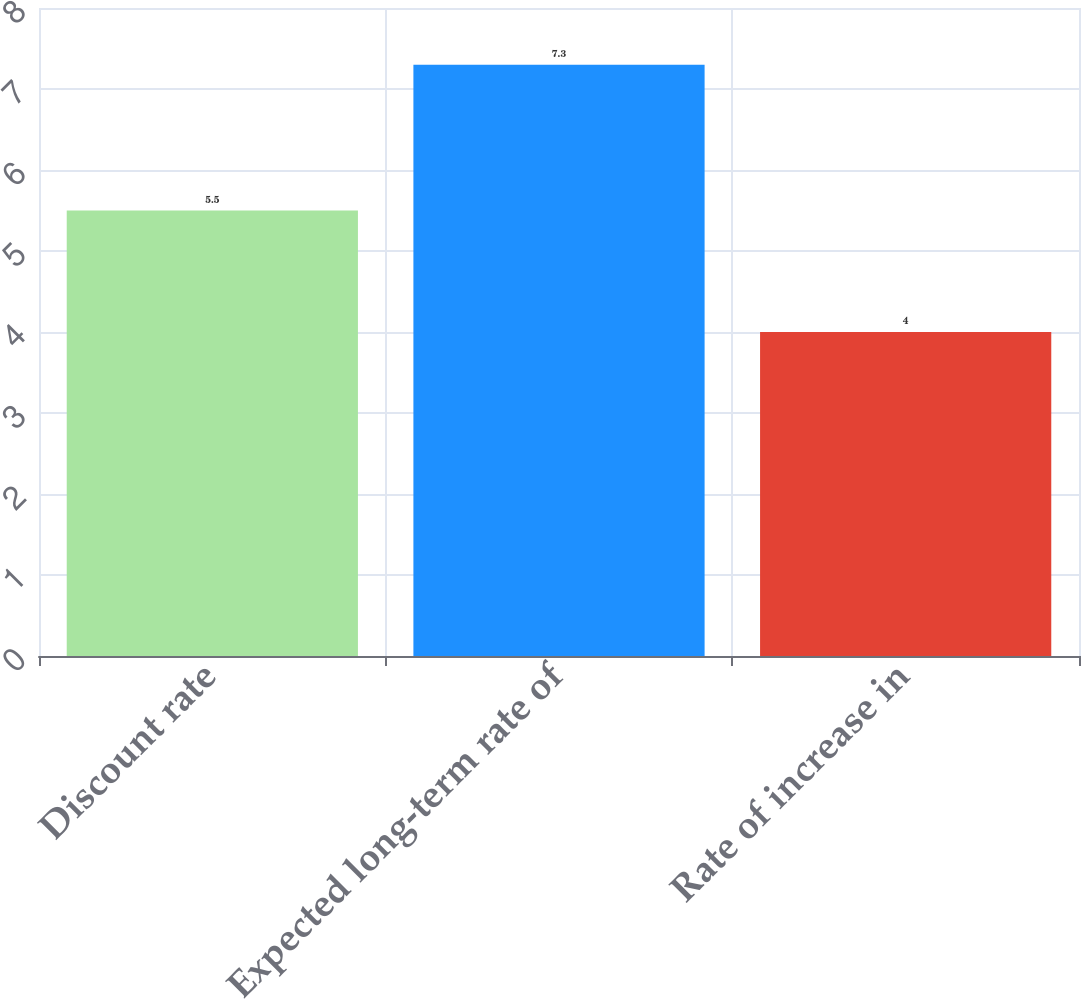Convert chart. <chart><loc_0><loc_0><loc_500><loc_500><bar_chart><fcel>Discount rate<fcel>Expected long-term rate of<fcel>Rate of increase in<nl><fcel>5.5<fcel>7.3<fcel>4<nl></chart> 